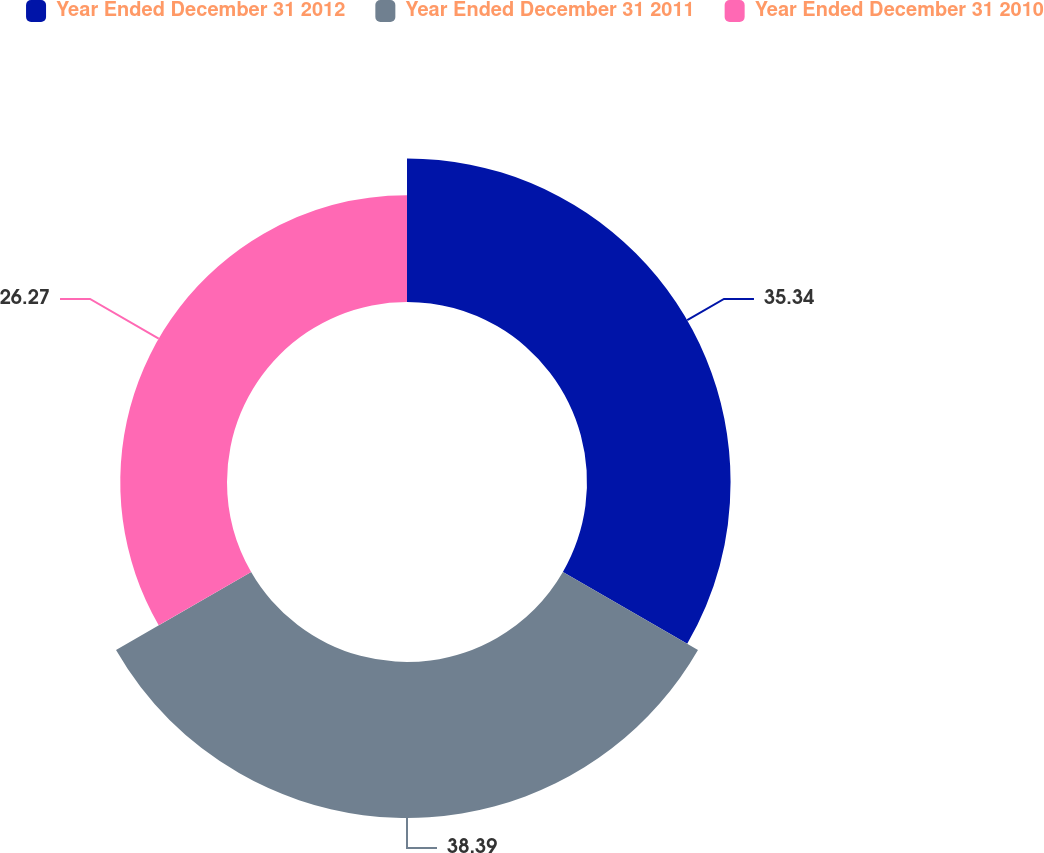Convert chart. <chart><loc_0><loc_0><loc_500><loc_500><pie_chart><fcel>Year Ended December 31 2012<fcel>Year Ended December 31 2011<fcel>Year Ended December 31 2010<nl><fcel>35.34%<fcel>38.4%<fcel>26.27%<nl></chart> 